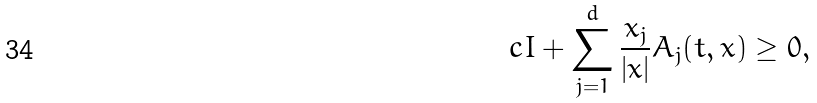Convert formula to latex. <formula><loc_0><loc_0><loc_500><loc_500>c I + \sum _ { j = 1 } ^ { d } \frac { x _ { j } } { | x | } A _ { j } ( t , x ) \geq 0 ,</formula> 